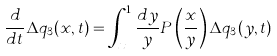Convert formula to latex. <formula><loc_0><loc_0><loc_500><loc_500>\frac { d } { d t } \Delta q _ { 3 } ( x , t ) = \int _ { x } ^ { 1 } \frac { d y } { y } P \left ( \frac { x } { y } \right ) \Delta q _ { 3 } ( y , t )</formula> 